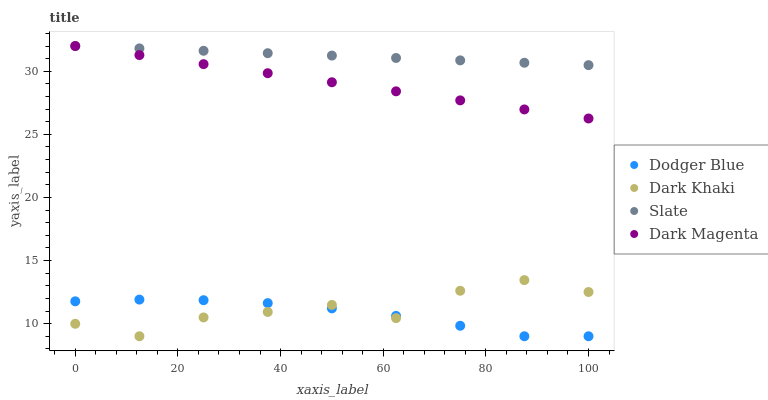Does Dodger Blue have the minimum area under the curve?
Answer yes or no. Yes. Does Slate have the maximum area under the curve?
Answer yes or no. Yes. Does Slate have the minimum area under the curve?
Answer yes or no. No. Does Dodger Blue have the maximum area under the curve?
Answer yes or no. No. Is Dark Magenta the smoothest?
Answer yes or no. Yes. Is Dark Khaki the roughest?
Answer yes or no. Yes. Is Slate the smoothest?
Answer yes or no. No. Is Slate the roughest?
Answer yes or no. No. Does Dark Khaki have the lowest value?
Answer yes or no. Yes. Does Slate have the lowest value?
Answer yes or no. No. Does Dark Magenta have the highest value?
Answer yes or no. Yes. Does Dodger Blue have the highest value?
Answer yes or no. No. Is Dark Khaki less than Dark Magenta?
Answer yes or no. Yes. Is Dark Magenta greater than Dodger Blue?
Answer yes or no. Yes. Does Dodger Blue intersect Dark Khaki?
Answer yes or no. Yes. Is Dodger Blue less than Dark Khaki?
Answer yes or no. No. Is Dodger Blue greater than Dark Khaki?
Answer yes or no. No. Does Dark Khaki intersect Dark Magenta?
Answer yes or no. No. 